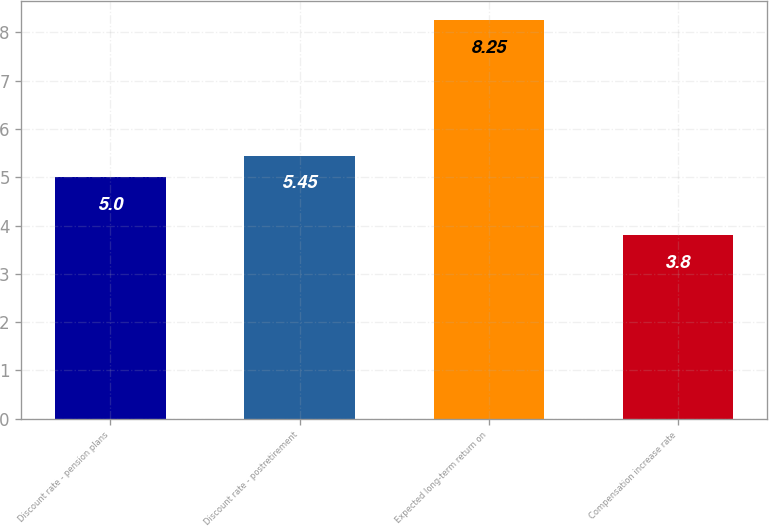<chart> <loc_0><loc_0><loc_500><loc_500><bar_chart><fcel>Discount rate - pension plans<fcel>Discount rate - postretirement<fcel>Expected long-term return on<fcel>Compensation increase rate<nl><fcel>5<fcel>5.45<fcel>8.25<fcel>3.8<nl></chart> 